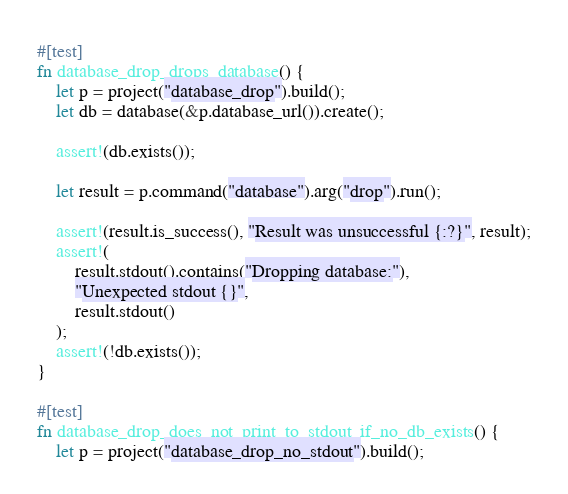Convert code to text. <code><loc_0><loc_0><loc_500><loc_500><_Rust_>#[test]
fn database_drop_drops_database() {
    let p = project("database_drop").build();
    let db = database(&p.database_url()).create();

    assert!(db.exists());

    let result = p.command("database").arg("drop").run();

    assert!(result.is_success(), "Result was unsuccessful {:?}", result);
    assert!(
        result.stdout().contains("Dropping database:"),
        "Unexpected stdout {}",
        result.stdout()
    );
    assert!(!db.exists());
}

#[test]
fn database_drop_does_not_print_to_stdout_if_no_db_exists() {
    let p = project("database_drop_no_stdout").build();</code> 